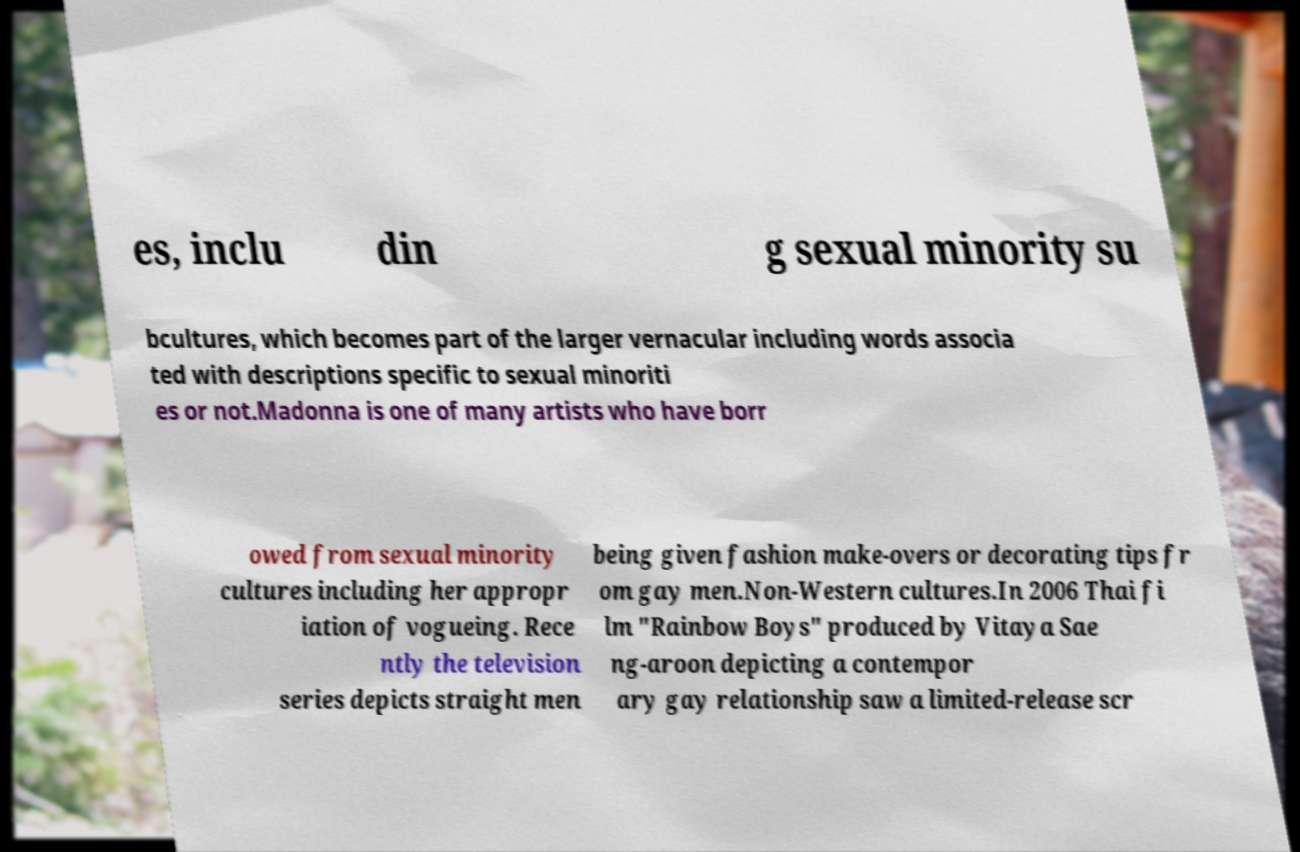Please identify and transcribe the text found in this image. es, inclu din g sexual minority su bcultures, which becomes part of the larger vernacular including words associa ted with descriptions specific to sexual minoriti es or not.Madonna is one of many artists who have borr owed from sexual minority cultures including her appropr iation of vogueing. Rece ntly the television series depicts straight men being given fashion make-overs or decorating tips fr om gay men.Non-Western cultures.In 2006 Thai fi lm "Rainbow Boys" produced by Vitaya Sae ng-aroon depicting a contempor ary gay relationship saw a limited-release scr 